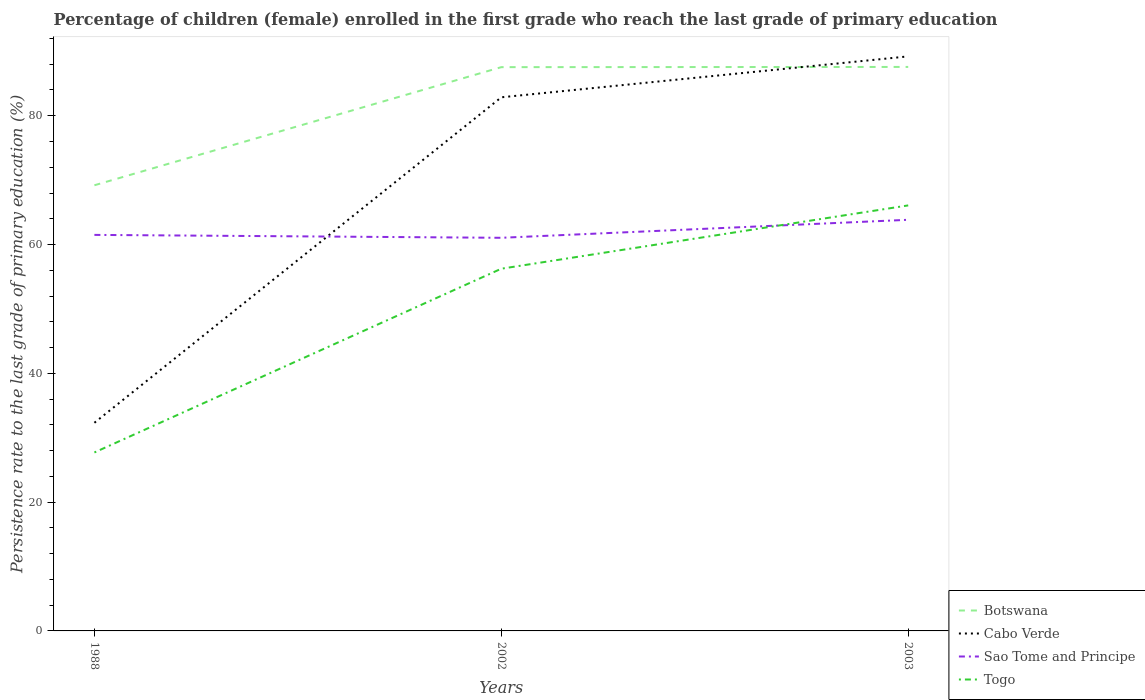How many different coloured lines are there?
Provide a short and direct response. 4. Does the line corresponding to Botswana intersect with the line corresponding to Sao Tome and Principe?
Offer a very short reply. No. Is the number of lines equal to the number of legend labels?
Your answer should be compact. Yes. Across all years, what is the maximum persistence rate of children in Togo?
Your answer should be compact. 27.71. What is the total persistence rate of children in Togo in the graph?
Offer a very short reply. -9.83. What is the difference between the highest and the second highest persistence rate of children in Botswana?
Make the answer very short. 18.38. Is the persistence rate of children in Sao Tome and Principe strictly greater than the persistence rate of children in Togo over the years?
Make the answer very short. No. How many lines are there?
Your response must be concise. 4. Are the values on the major ticks of Y-axis written in scientific E-notation?
Provide a short and direct response. No. Does the graph contain any zero values?
Your answer should be compact. No. Where does the legend appear in the graph?
Provide a short and direct response. Bottom right. What is the title of the graph?
Your answer should be compact. Percentage of children (female) enrolled in the first grade who reach the last grade of primary education. Does "Jordan" appear as one of the legend labels in the graph?
Offer a terse response. No. What is the label or title of the Y-axis?
Ensure brevity in your answer.  Persistence rate to the last grade of primary education (%). What is the Persistence rate to the last grade of primary education (%) of Botswana in 1988?
Offer a very short reply. 69.21. What is the Persistence rate to the last grade of primary education (%) in Cabo Verde in 1988?
Your answer should be very brief. 32.32. What is the Persistence rate to the last grade of primary education (%) of Sao Tome and Principe in 1988?
Keep it short and to the point. 61.5. What is the Persistence rate to the last grade of primary education (%) in Togo in 1988?
Your answer should be very brief. 27.71. What is the Persistence rate to the last grade of primary education (%) of Botswana in 2002?
Your answer should be very brief. 87.55. What is the Persistence rate to the last grade of primary education (%) in Cabo Verde in 2002?
Ensure brevity in your answer.  82.87. What is the Persistence rate to the last grade of primary education (%) of Sao Tome and Principe in 2002?
Keep it short and to the point. 61.05. What is the Persistence rate to the last grade of primary education (%) in Togo in 2002?
Make the answer very short. 56.25. What is the Persistence rate to the last grade of primary education (%) in Botswana in 2003?
Offer a very short reply. 87.58. What is the Persistence rate to the last grade of primary education (%) of Cabo Verde in 2003?
Your answer should be very brief. 89.22. What is the Persistence rate to the last grade of primary education (%) of Sao Tome and Principe in 2003?
Make the answer very short. 63.84. What is the Persistence rate to the last grade of primary education (%) in Togo in 2003?
Offer a terse response. 66.08. Across all years, what is the maximum Persistence rate to the last grade of primary education (%) of Botswana?
Your answer should be compact. 87.58. Across all years, what is the maximum Persistence rate to the last grade of primary education (%) of Cabo Verde?
Offer a terse response. 89.22. Across all years, what is the maximum Persistence rate to the last grade of primary education (%) in Sao Tome and Principe?
Ensure brevity in your answer.  63.84. Across all years, what is the maximum Persistence rate to the last grade of primary education (%) of Togo?
Provide a succinct answer. 66.08. Across all years, what is the minimum Persistence rate to the last grade of primary education (%) in Botswana?
Provide a short and direct response. 69.21. Across all years, what is the minimum Persistence rate to the last grade of primary education (%) of Cabo Verde?
Your answer should be compact. 32.32. Across all years, what is the minimum Persistence rate to the last grade of primary education (%) in Sao Tome and Principe?
Make the answer very short. 61.05. Across all years, what is the minimum Persistence rate to the last grade of primary education (%) of Togo?
Your response must be concise. 27.71. What is the total Persistence rate to the last grade of primary education (%) in Botswana in the graph?
Your answer should be very brief. 244.34. What is the total Persistence rate to the last grade of primary education (%) in Cabo Verde in the graph?
Provide a short and direct response. 204.41. What is the total Persistence rate to the last grade of primary education (%) in Sao Tome and Principe in the graph?
Ensure brevity in your answer.  186.39. What is the total Persistence rate to the last grade of primary education (%) in Togo in the graph?
Offer a terse response. 150.04. What is the difference between the Persistence rate to the last grade of primary education (%) in Botswana in 1988 and that in 2002?
Ensure brevity in your answer.  -18.34. What is the difference between the Persistence rate to the last grade of primary education (%) in Cabo Verde in 1988 and that in 2002?
Keep it short and to the point. -50.54. What is the difference between the Persistence rate to the last grade of primary education (%) of Sao Tome and Principe in 1988 and that in 2002?
Give a very brief answer. 0.45. What is the difference between the Persistence rate to the last grade of primary education (%) of Togo in 1988 and that in 2002?
Keep it short and to the point. -28.54. What is the difference between the Persistence rate to the last grade of primary education (%) of Botswana in 1988 and that in 2003?
Ensure brevity in your answer.  -18.38. What is the difference between the Persistence rate to the last grade of primary education (%) in Cabo Verde in 1988 and that in 2003?
Provide a succinct answer. -56.9. What is the difference between the Persistence rate to the last grade of primary education (%) in Sao Tome and Principe in 1988 and that in 2003?
Ensure brevity in your answer.  -2.35. What is the difference between the Persistence rate to the last grade of primary education (%) of Togo in 1988 and that in 2003?
Provide a succinct answer. -38.36. What is the difference between the Persistence rate to the last grade of primary education (%) in Botswana in 2002 and that in 2003?
Provide a short and direct response. -0.03. What is the difference between the Persistence rate to the last grade of primary education (%) in Cabo Verde in 2002 and that in 2003?
Provide a succinct answer. -6.35. What is the difference between the Persistence rate to the last grade of primary education (%) of Sao Tome and Principe in 2002 and that in 2003?
Provide a succinct answer. -2.8. What is the difference between the Persistence rate to the last grade of primary education (%) of Togo in 2002 and that in 2003?
Keep it short and to the point. -9.83. What is the difference between the Persistence rate to the last grade of primary education (%) of Botswana in 1988 and the Persistence rate to the last grade of primary education (%) of Cabo Verde in 2002?
Provide a succinct answer. -13.66. What is the difference between the Persistence rate to the last grade of primary education (%) in Botswana in 1988 and the Persistence rate to the last grade of primary education (%) in Sao Tome and Principe in 2002?
Offer a terse response. 8.16. What is the difference between the Persistence rate to the last grade of primary education (%) in Botswana in 1988 and the Persistence rate to the last grade of primary education (%) in Togo in 2002?
Keep it short and to the point. 12.96. What is the difference between the Persistence rate to the last grade of primary education (%) in Cabo Verde in 1988 and the Persistence rate to the last grade of primary education (%) in Sao Tome and Principe in 2002?
Give a very brief answer. -28.72. What is the difference between the Persistence rate to the last grade of primary education (%) in Cabo Verde in 1988 and the Persistence rate to the last grade of primary education (%) in Togo in 2002?
Your response must be concise. -23.92. What is the difference between the Persistence rate to the last grade of primary education (%) in Sao Tome and Principe in 1988 and the Persistence rate to the last grade of primary education (%) in Togo in 2002?
Offer a very short reply. 5.25. What is the difference between the Persistence rate to the last grade of primary education (%) of Botswana in 1988 and the Persistence rate to the last grade of primary education (%) of Cabo Verde in 2003?
Ensure brevity in your answer.  -20.01. What is the difference between the Persistence rate to the last grade of primary education (%) in Botswana in 1988 and the Persistence rate to the last grade of primary education (%) in Sao Tome and Principe in 2003?
Your response must be concise. 5.36. What is the difference between the Persistence rate to the last grade of primary education (%) of Botswana in 1988 and the Persistence rate to the last grade of primary education (%) of Togo in 2003?
Your response must be concise. 3.13. What is the difference between the Persistence rate to the last grade of primary education (%) in Cabo Verde in 1988 and the Persistence rate to the last grade of primary education (%) in Sao Tome and Principe in 2003?
Provide a short and direct response. -31.52. What is the difference between the Persistence rate to the last grade of primary education (%) in Cabo Verde in 1988 and the Persistence rate to the last grade of primary education (%) in Togo in 2003?
Keep it short and to the point. -33.75. What is the difference between the Persistence rate to the last grade of primary education (%) in Sao Tome and Principe in 1988 and the Persistence rate to the last grade of primary education (%) in Togo in 2003?
Make the answer very short. -4.58. What is the difference between the Persistence rate to the last grade of primary education (%) of Botswana in 2002 and the Persistence rate to the last grade of primary education (%) of Cabo Verde in 2003?
Make the answer very short. -1.67. What is the difference between the Persistence rate to the last grade of primary education (%) in Botswana in 2002 and the Persistence rate to the last grade of primary education (%) in Sao Tome and Principe in 2003?
Your response must be concise. 23.7. What is the difference between the Persistence rate to the last grade of primary education (%) of Botswana in 2002 and the Persistence rate to the last grade of primary education (%) of Togo in 2003?
Provide a short and direct response. 21.47. What is the difference between the Persistence rate to the last grade of primary education (%) of Cabo Verde in 2002 and the Persistence rate to the last grade of primary education (%) of Sao Tome and Principe in 2003?
Ensure brevity in your answer.  19.02. What is the difference between the Persistence rate to the last grade of primary education (%) in Cabo Verde in 2002 and the Persistence rate to the last grade of primary education (%) in Togo in 2003?
Your response must be concise. 16.79. What is the difference between the Persistence rate to the last grade of primary education (%) in Sao Tome and Principe in 2002 and the Persistence rate to the last grade of primary education (%) in Togo in 2003?
Your answer should be compact. -5.03. What is the average Persistence rate to the last grade of primary education (%) of Botswana per year?
Ensure brevity in your answer.  81.45. What is the average Persistence rate to the last grade of primary education (%) of Cabo Verde per year?
Your answer should be very brief. 68.14. What is the average Persistence rate to the last grade of primary education (%) in Sao Tome and Principe per year?
Your answer should be very brief. 62.13. What is the average Persistence rate to the last grade of primary education (%) in Togo per year?
Keep it short and to the point. 50.01. In the year 1988, what is the difference between the Persistence rate to the last grade of primary education (%) in Botswana and Persistence rate to the last grade of primary education (%) in Cabo Verde?
Offer a terse response. 36.88. In the year 1988, what is the difference between the Persistence rate to the last grade of primary education (%) of Botswana and Persistence rate to the last grade of primary education (%) of Sao Tome and Principe?
Offer a very short reply. 7.71. In the year 1988, what is the difference between the Persistence rate to the last grade of primary education (%) in Botswana and Persistence rate to the last grade of primary education (%) in Togo?
Your answer should be very brief. 41.49. In the year 1988, what is the difference between the Persistence rate to the last grade of primary education (%) of Cabo Verde and Persistence rate to the last grade of primary education (%) of Sao Tome and Principe?
Your response must be concise. -29.17. In the year 1988, what is the difference between the Persistence rate to the last grade of primary education (%) in Cabo Verde and Persistence rate to the last grade of primary education (%) in Togo?
Keep it short and to the point. 4.61. In the year 1988, what is the difference between the Persistence rate to the last grade of primary education (%) of Sao Tome and Principe and Persistence rate to the last grade of primary education (%) of Togo?
Provide a short and direct response. 33.79. In the year 2002, what is the difference between the Persistence rate to the last grade of primary education (%) of Botswana and Persistence rate to the last grade of primary education (%) of Cabo Verde?
Offer a very short reply. 4.68. In the year 2002, what is the difference between the Persistence rate to the last grade of primary education (%) in Botswana and Persistence rate to the last grade of primary education (%) in Sao Tome and Principe?
Make the answer very short. 26.5. In the year 2002, what is the difference between the Persistence rate to the last grade of primary education (%) of Botswana and Persistence rate to the last grade of primary education (%) of Togo?
Give a very brief answer. 31.3. In the year 2002, what is the difference between the Persistence rate to the last grade of primary education (%) in Cabo Verde and Persistence rate to the last grade of primary education (%) in Sao Tome and Principe?
Ensure brevity in your answer.  21.82. In the year 2002, what is the difference between the Persistence rate to the last grade of primary education (%) in Cabo Verde and Persistence rate to the last grade of primary education (%) in Togo?
Provide a succinct answer. 26.62. In the year 2002, what is the difference between the Persistence rate to the last grade of primary education (%) in Sao Tome and Principe and Persistence rate to the last grade of primary education (%) in Togo?
Make the answer very short. 4.8. In the year 2003, what is the difference between the Persistence rate to the last grade of primary education (%) in Botswana and Persistence rate to the last grade of primary education (%) in Cabo Verde?
Your answer should be very brief. -1.64. In the year 2003, what is the difference between the Persistence rate to the last grade of primary education (%) in Botswana and Persistence rate to the last grade of primary education (%) in Sao Tome and Principe?
Your response must be concise. 23.74. In the year 2003, what is the difference between the Persistence rate to the last grade of primary education (%) in Botswana and Persistence rate to the last grade of primary education (%) in Togo?
Your answer should be compact. 21.5. In the year 2003, what is the difference between the Persistence rate to the last grade of primary education (%) of Cabo Verde and Persistence rate to the last grade of primary education (%) of Sao Tome and Principe?
Provide a succinct answer. 25.38. In the year 2003, what is the difference between the Persistence rate to the last grade of primary education (%) in Cabo Verde and Persistence rate to the last grade of primary education (%) in Togo?
Keep it short and to the point. 23.14. In the year 2003, what is the difference between the Persistence rate to the last grade of primary education (%) in Sao Tome and Principe and Persistence rate to the last grade of primary education (%) in Togo?
Your answer should be very brief. -2.23. What is the ratio of the Persistence rate to the last grade of primary education (%) of Botswana in 1988 to that in 2002?
Give a very brief answer. 0.79. What is the ratio of the Persistence rate to the last grade of primary education (%) of Cabo Verde in 1988 to that in 2002?
Make the answer very short. 0.39. What is the ratio of the Persistence rate to the last grade of primary education (%) in Sao Tome and Principe in 1988 to that in 2002?
Your response must be concise. 1.01. What is the ratio of the Persistence rate to the last grade of primary education (%) of Togo in 1988 to that in 2002?
Ensure brevity in your answer.  0.49. What is the ratio of the Persistence rate to the last grade of primary education (%) of Botswana in 1988 to that in 2003?
Provide a short and direct response. 0.79. What is the ratio of the Persistence rate to the last grade of primary education (%) of Cabo Verde in 1988 to that in 2003?
Ensure brevity in your answer.  0.36. What is the ratio of the Persistence rate to the last grade of primary education (%) of Sao Tome and Principe in 1988 to that in 2003?
Provide a succinct answer. 0.96. What is the ratio of the Persistence rate to the last grade of primary education (%) in Togo in 1988 to that in 2003?
Give a very brief answer. 0.42. What is the ratio of the Persistence rate to the last grade of primary education (%) of Cabo Verde in 2002 to that in 2003?
Provide a succinct answer. 0.93. What is the ratio of the Persistence rate to the last grade of primary education (%) in Sao Tome and Principe in 2002 to that in 2003?
Offer a terse response. 0.96. What is the ratio of the Persistence rate to the last grade of primary education (%) in Togo in 2002 to that in 2003?
Offer a very short reply. 0.85. What is the difference between the highest and the second highest Persistence rate to the last grade of primary education (%) of Cabo Verde?
Your answer should be very brief. 6.35. What is the difference between the highest and the second highest Persistence rate to the last grade of primary education (%) in Sao Tome and Principe?
Keep it short and to the point. 2.35. What is the difference between the highest and the second highest Persistence rate to the last grade of primary education (%) of Togo?
Your response must be concise. 9.83. What is the difference between the highest and the lowest Persistence rate to the last grade of primary education (%) of Botswana?
Your answer should be very brief. 18.38. What is the difference between the highest and the lowest Persistence rate to the last grade of primary education (%) in Cabo Verde?
Offer a terse response. 56.9. What is the difference between the highest and the lowest Persistence rate to the last grade of primary education (%) of Sao Tome and Principe?
Your answer should be very brief. 2.8. What is the difference between the highest and the lowest Persistence rate to the last grade of primary education (%) of Togo?
Provide a short and direct response. 38.36. 